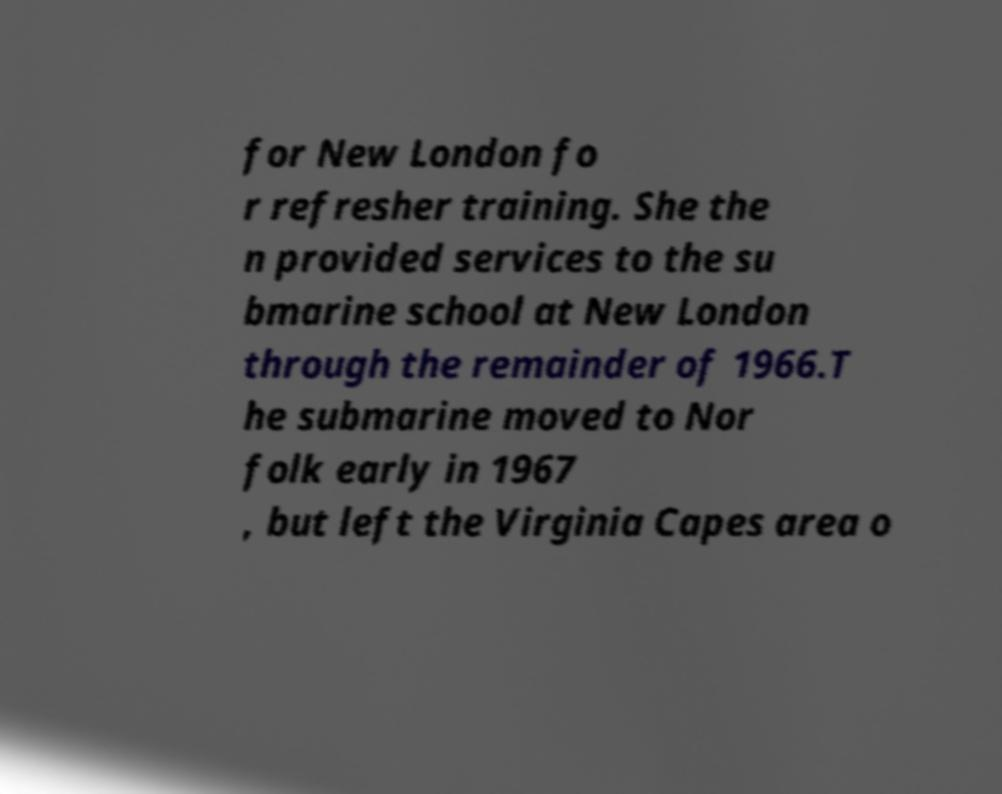For documentation purposes, I need the text within this image transcribed. Could you provide that? for New London fo r refresher training. She the n provided services to the su bmarine school at New London through the remainder of 1966.T he submarine moved to Nor folk early in 1967 , but left the Virginia Capes area o 